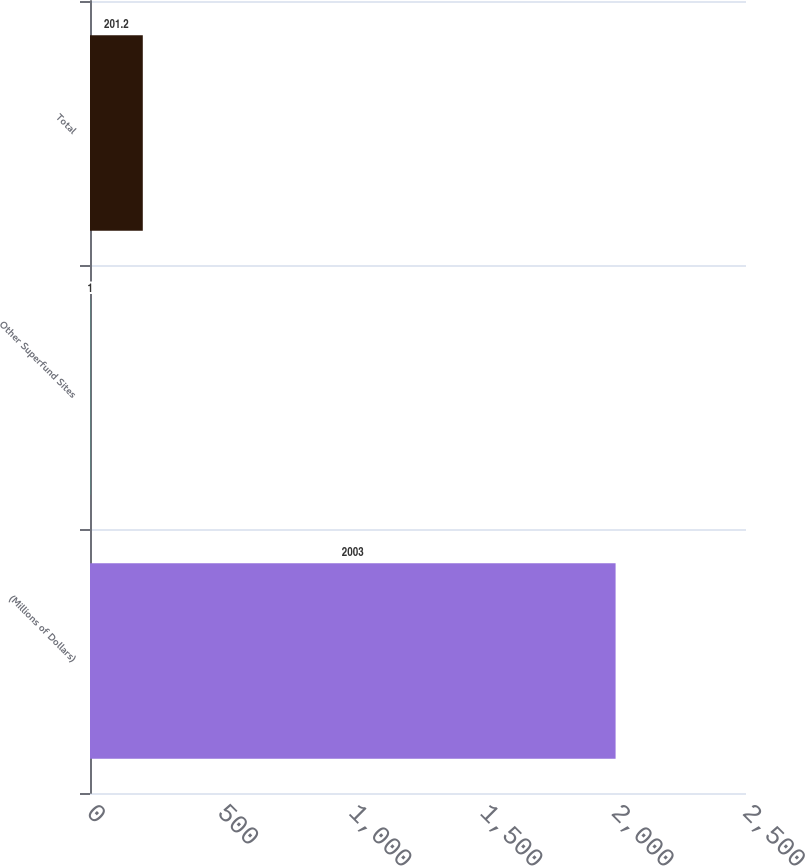Convert chart to OTSL. <chart><loc_0><loc_0><loc_500><loc_500><bar_chart><fcel>(Millions of Dollars)<fcel>Other Superfund Sites<fcel>Total<nl><fcel>2003<fcel>1<fcel>201.2<nl></chart> 